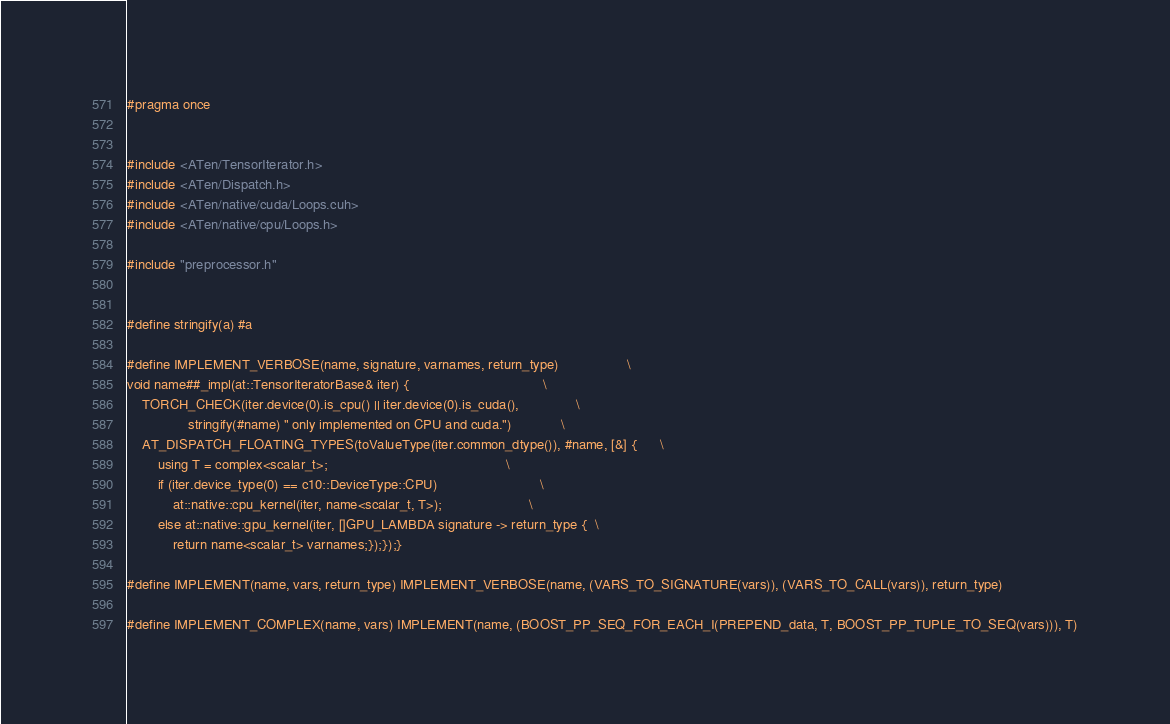<code> <loc_0><loc_0><loc_500><loc_500><_Cuda_>#pragma once


#include <ATen/TensorIterator.h>
#include <ATen/Dispatch.h>
#include <ATen/native/cuda/Loops.cuh>
#include <ATen/native/cpu/Loops.h>

#include "preprocessor.h"


#define stringify(a) #a

#define IMPLEMENT_VERBOSE(name, signature, varnames, return_type)                  \
void name##_impl(at::TensorIteratorBase& iter) {                                   \
    TORCH_CHECK(iter.device(0).is_cpu() || iter.device(0).is_cuda(),               \
                stringify(#name) " only implemented on CPU and cuda.")             \
    AT_DISPATCH_FLOATING_TYPES(toValueType(iter.common_dtype()), #name, [&] {      \
        using T = complex<scalar_t>;                                               \
        if (iter.device_type(0) == c10::DeviceType::CPU)                           \
            at::native::cpu_kernel(iter, name<scalar_t, T>);                       \
        else at::native::gpu_kernel(iter, []GPU_LAMBDA signature -> return_type {  \
            return name<scalar_t> varnames;});});}

#define IMPLEMENT(name, vars, return_type) IMPLEMENT_VERBOSE(name, (VARS_TO_SIGNATURE(vars)), (VARS_TO_CALL(vars)), return_type)

#define IMPLEMENT_COMPLEX(name, vars) IMPLEMENT(name, (BOOST_PP_SEQ_FOR_EACH_I(PREPEND_data, T, BOOST_PP_TUPLE_TO_SEQ(vars))), T)
</code> 